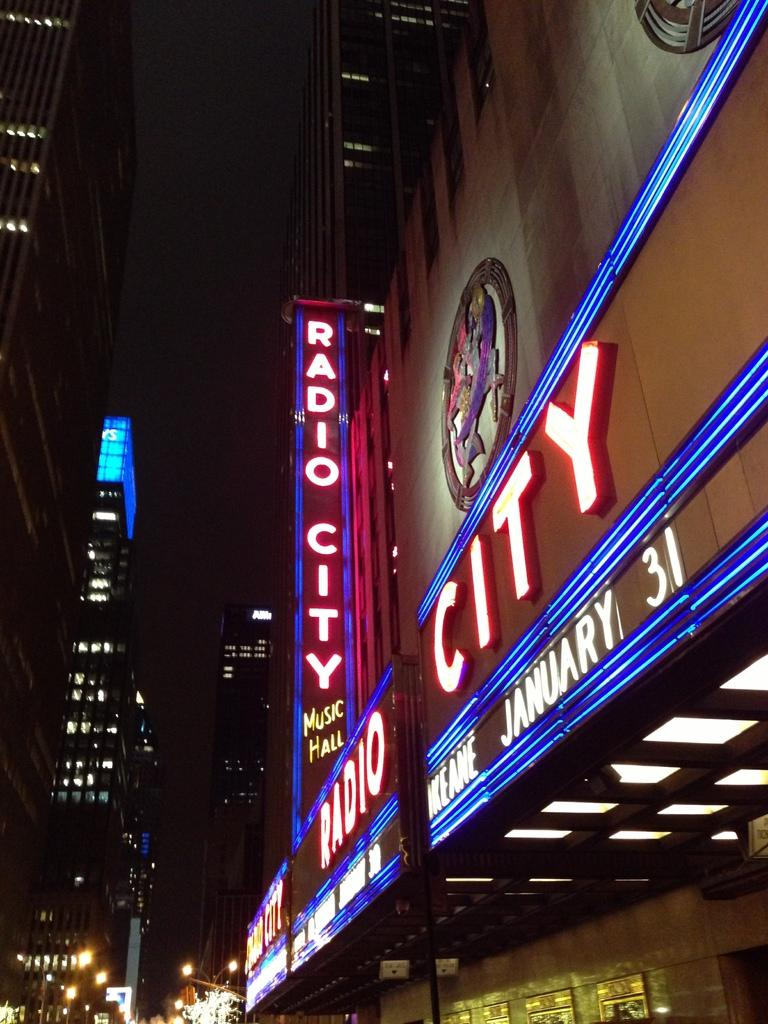What type of structures can be seen in the image? There are buildings in the image. What electronic devices are present in the image? There are LED boards in the image. What type of lighting is visible in the image? There are street lights in the image. How would you describe the overall lighting in the image? The background of the image is dark. What type of amusement can be seen on the sidewalk in the image? There is no amusement or sidewalk present in the image. How many cellars are visible in the image? There are no cellars visible in the image. 